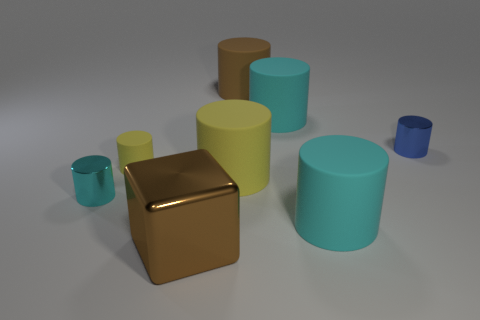What is the shape of the shiny object that is both on the left side of the large yellow rubber cylinder and behind the brown cube?
Your answer should be compact. Cylinder. What number of cubes are the same material as the blue object?
Offer a very short reply. 1. Is the number of yellow matte things that are in front of the brown metallic cube less than the number of cylinders?
Provide a short and direct response. Yes. There is a tiny blue cylinder that is right of the brown matte cylinder; are there any brown metallic things left of it?
Your response must be concise. Yes. Are there any other things that are the same shape as the big brown metal thing?
Keep it short and to the point. No. Does the blue metallic object have the same size as the brown cylinder?
Give a very brief answer. No. What is the large cylinder that is right of the cyan object behind the metallic thing right of the large shiny thing made of?
Your answer should be very brief. Rubber. Are there an equal number of tiny blue things that are behind the big brown rubber object and cyan rubber objects?
Give a very brief answer. No. Is there any other thing that has the same size as the brown matte object?
Your response must be concise. Yes. How many things are either rubber objects or tiny purple things?
Offer a very short reply. 5. 